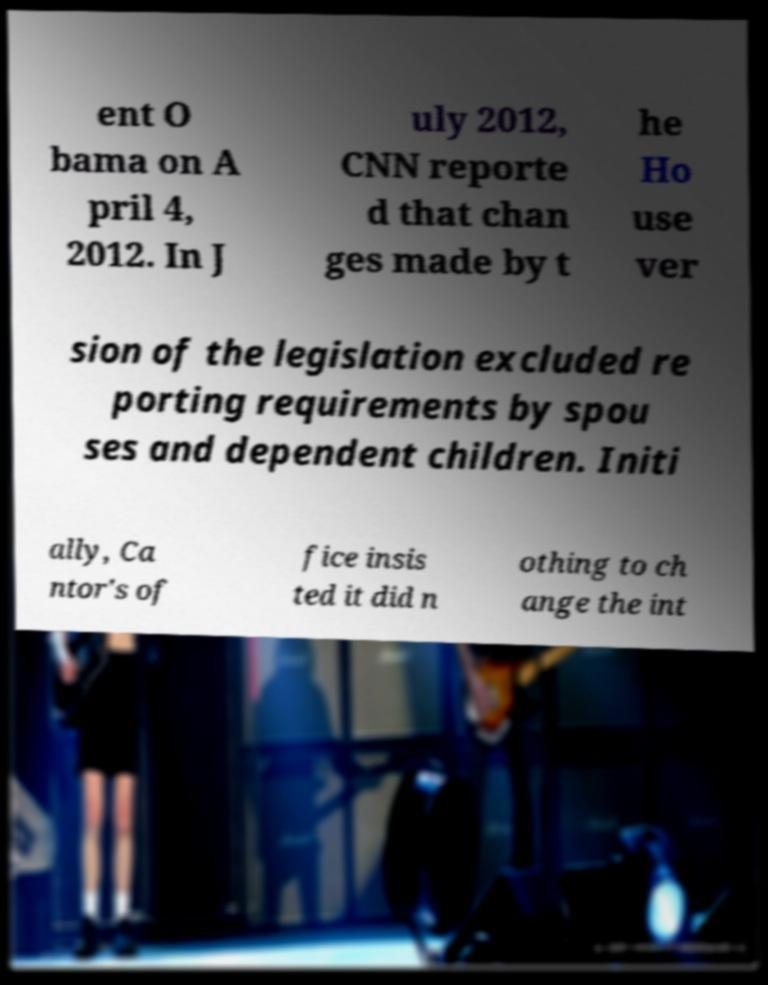Please read and relay the text visible in this image. What does it say? ent O bama on A pril 4, 2012. In J uly 2012, CNN reporte d that chan ges made by t he Ho use ver sion of the legislation excluded re porting requirements by spou ses and dependent children. Initi ally, Ca ntor's of fice insis ted it did n othing to ch ange the int 